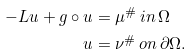Convert formula to latex. <formula><loc_0><loc_0><loc_500><loc_500>- L u + g \circ u & = \mu ^ { \# } \, i n \, \Omega \\ u & = \nu ^ { \# } \, o n \, \partial \Omega .</formula> 